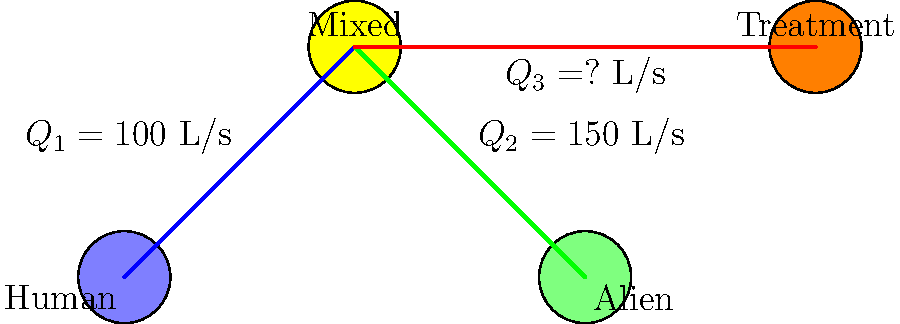In the frontier town's water supply system shown above, what is the flow rate $Q_3$ in the pipe connecting the mixed reservoir to the treatment facility, given that the human reservoir supplies 100 L/s and the alien reservoir supplies 150 L/s? To solve this problem, we need to apply the principle of conservation of mass in fluid mechanics, which is analogous to Kirchhoff's current law in electrical circuits. Here's the step-by-step solution:

1. Identify the known flow rates:
   - Human reservoir output ($Q_1$) = 100 L/s
   - Alien reservoir output ($Q_2$) = 150 L/s

2. Apply the conservation of mass principle at the mixed reservoir (node C):
   - The total inflow must equal the total outflow
   - Inflow = $Q_1 + Q_2$
   - Outflow = $Q_3$

3. Set up the equation:
   $Q_1 + Q_2 = Q_3$

4. Substitute the known values:
   $100 \text{ L/s} + 150 \text{ L/s} = Q_3$

5. Solve for $Q_3$:
   $Q_3 = 100 \text{ L/s} + 150 \text{ L/s} = 250 \text{ L/s}$

Therefore, the flow rate $Q_3$ in the pipe connecting the mixed reservoir to the treatment facility is 250 L/s.
Answer: 250 L/s 